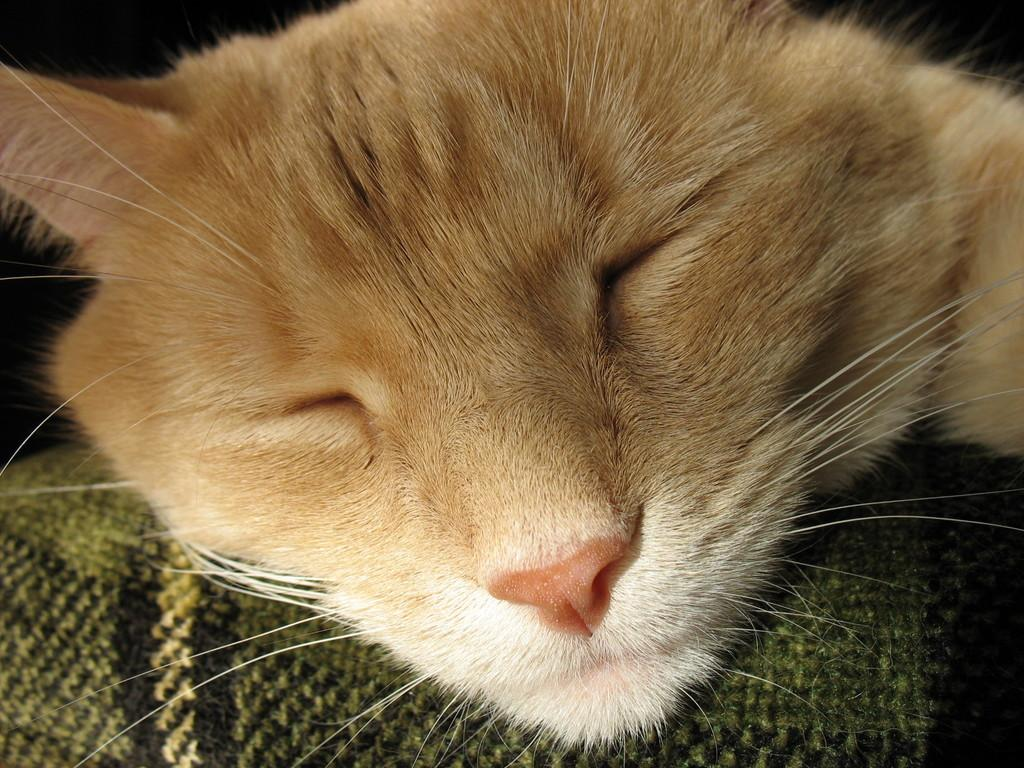What type of animal is in the image? There is a cat in the image. What stage of development is the pancake in the image? There is no pancake present in the image; it only features a cat. 